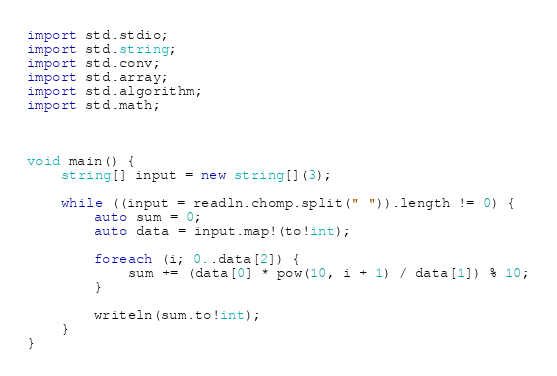<code> <loc_0><loc_0><loc_500><loc_500><_D_>import std.stdio;
import std.string;
import std.conv;
import std.array;
import std.algorithm;
import std.math;



void main() {
    string[] input = new string[](3);

    while ((input = readln.chomp.split(" ")).length != 0) {
        auto sum = 0;
        auto data = input.map!(to!int);

        foreach (i; 0..data[2]) {
            sum += (data[0] * pow(10, i + 1) / data[1]) % 10;
        }

        writeln(sum.to!int);
    }
}</code> 